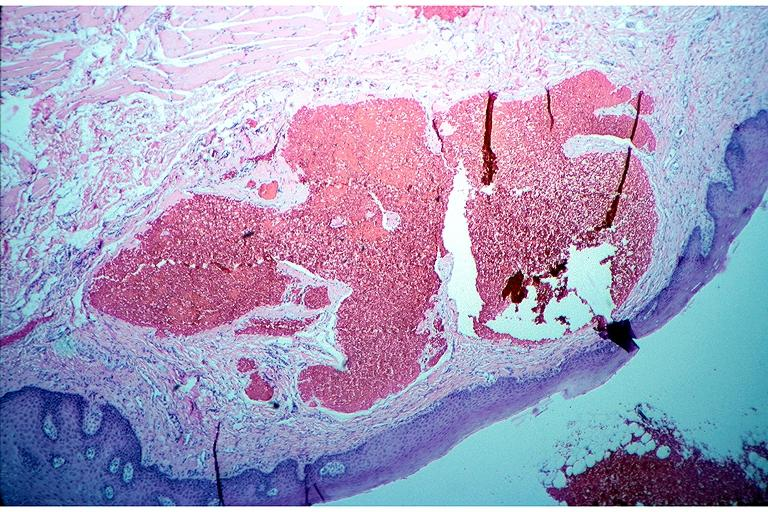what does this image show?
Answer the question using a single word or phrase. Cavernous hemangioma 